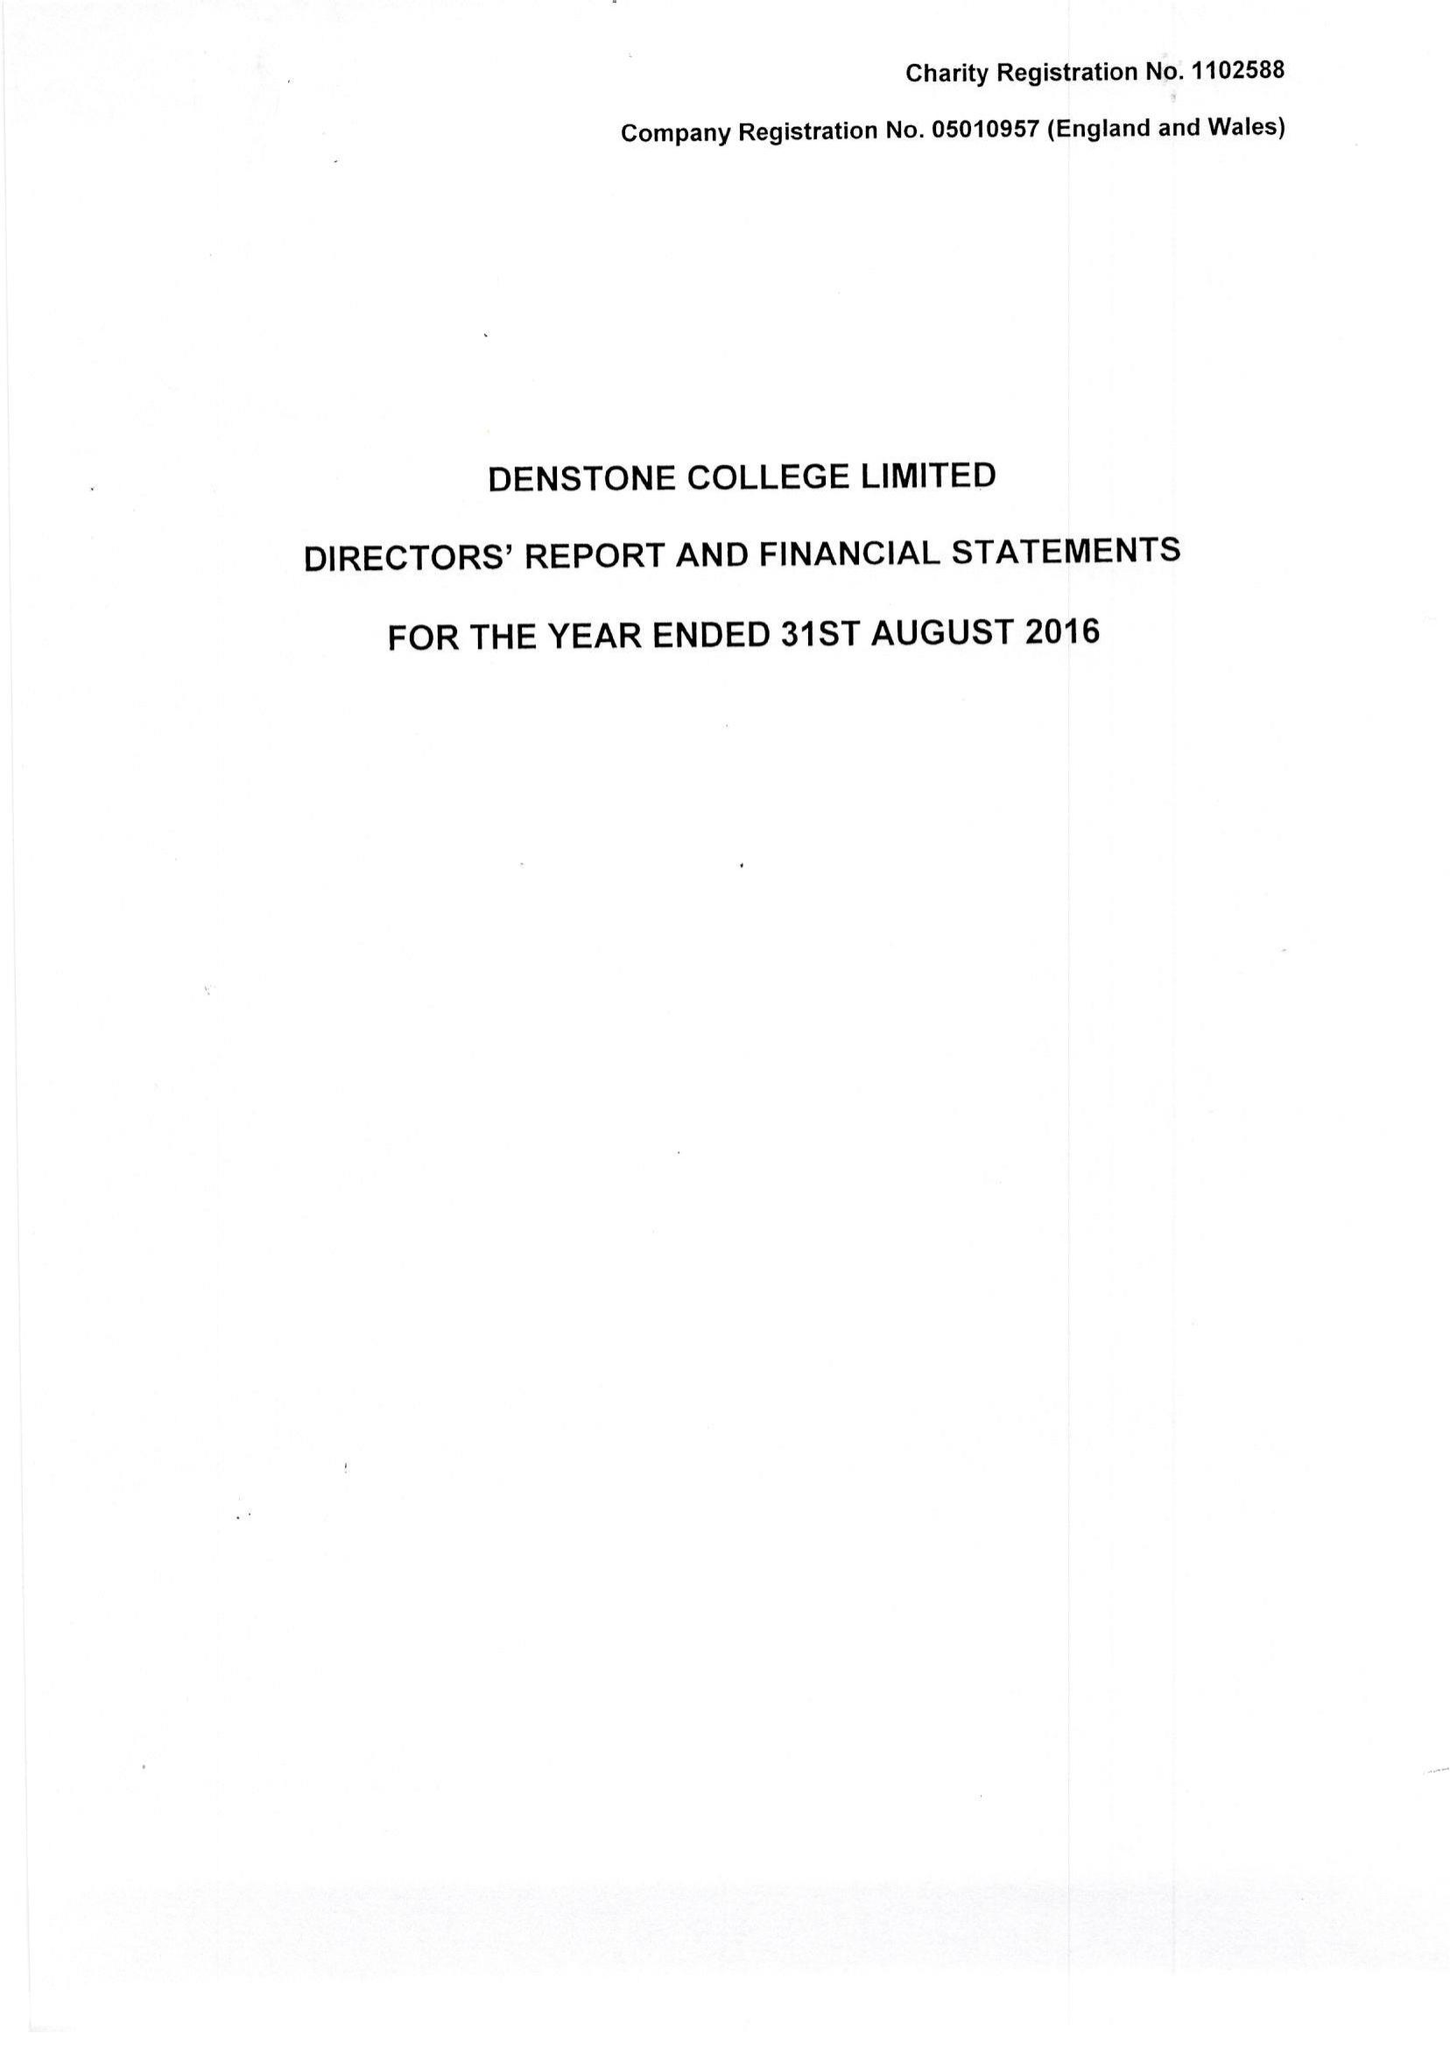What is the value for the income_annually_in_british_pounds?
Answer the question using a single word or phrase. 9264906.00 